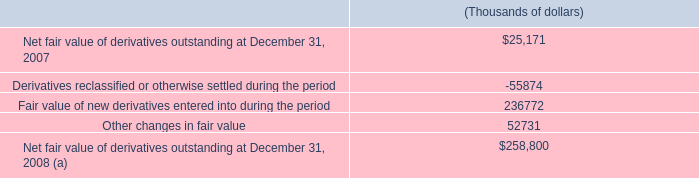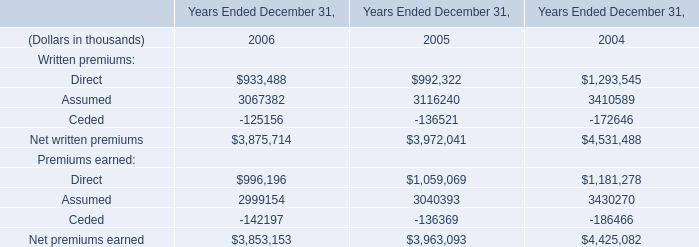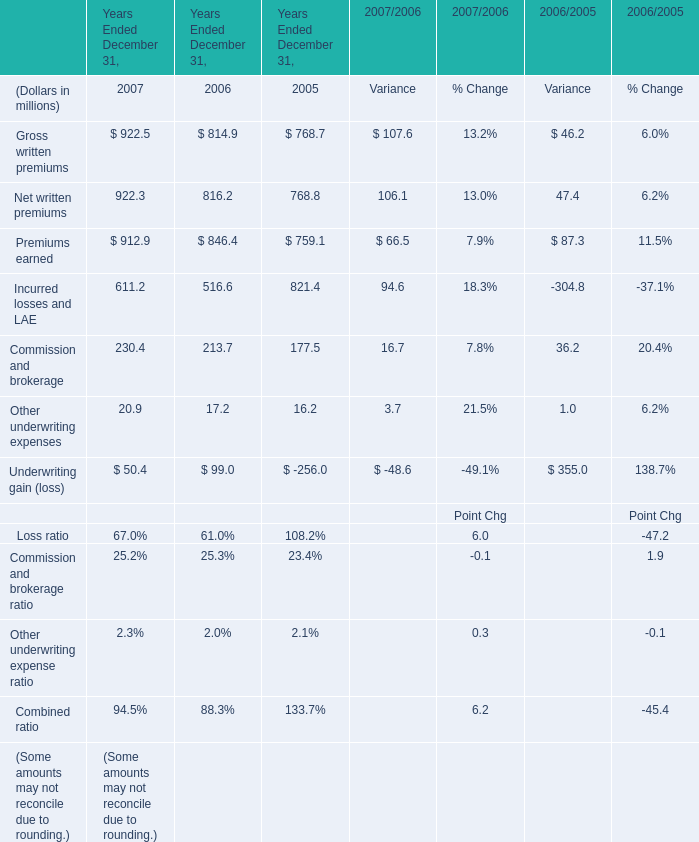what was the percentage change in net fair value of derivatives outstanding at between 2007 and 2008 in thousands? 
Computations: ((258800 - 25171) / 25171)
Answer: 9.28167. 